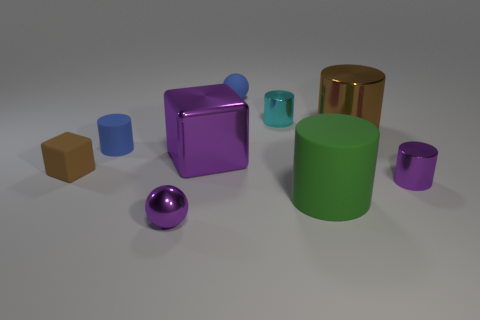Subtract all cylinders. How many objects are left? 4 Subtract all large green matte cylinders. How many cylinders are left? 4 Subtract all brown cubes. How many cubes are left? 1 Subtract all gray cylinders. How many red spheres are left? 0 Subtract all large green things. Subtract all green objects. How many objects are left? 7 Add 7 tiny purple spheres. How many tiny purple spheres are left? 8 Add 3 cyan objects. How many cyan objects exist? 4 Subtract 1 brown cylinders. How many objects are left? 8 Subtract all brown cylinders. Subtract all gray blocks. How many cylinders are left? 4 